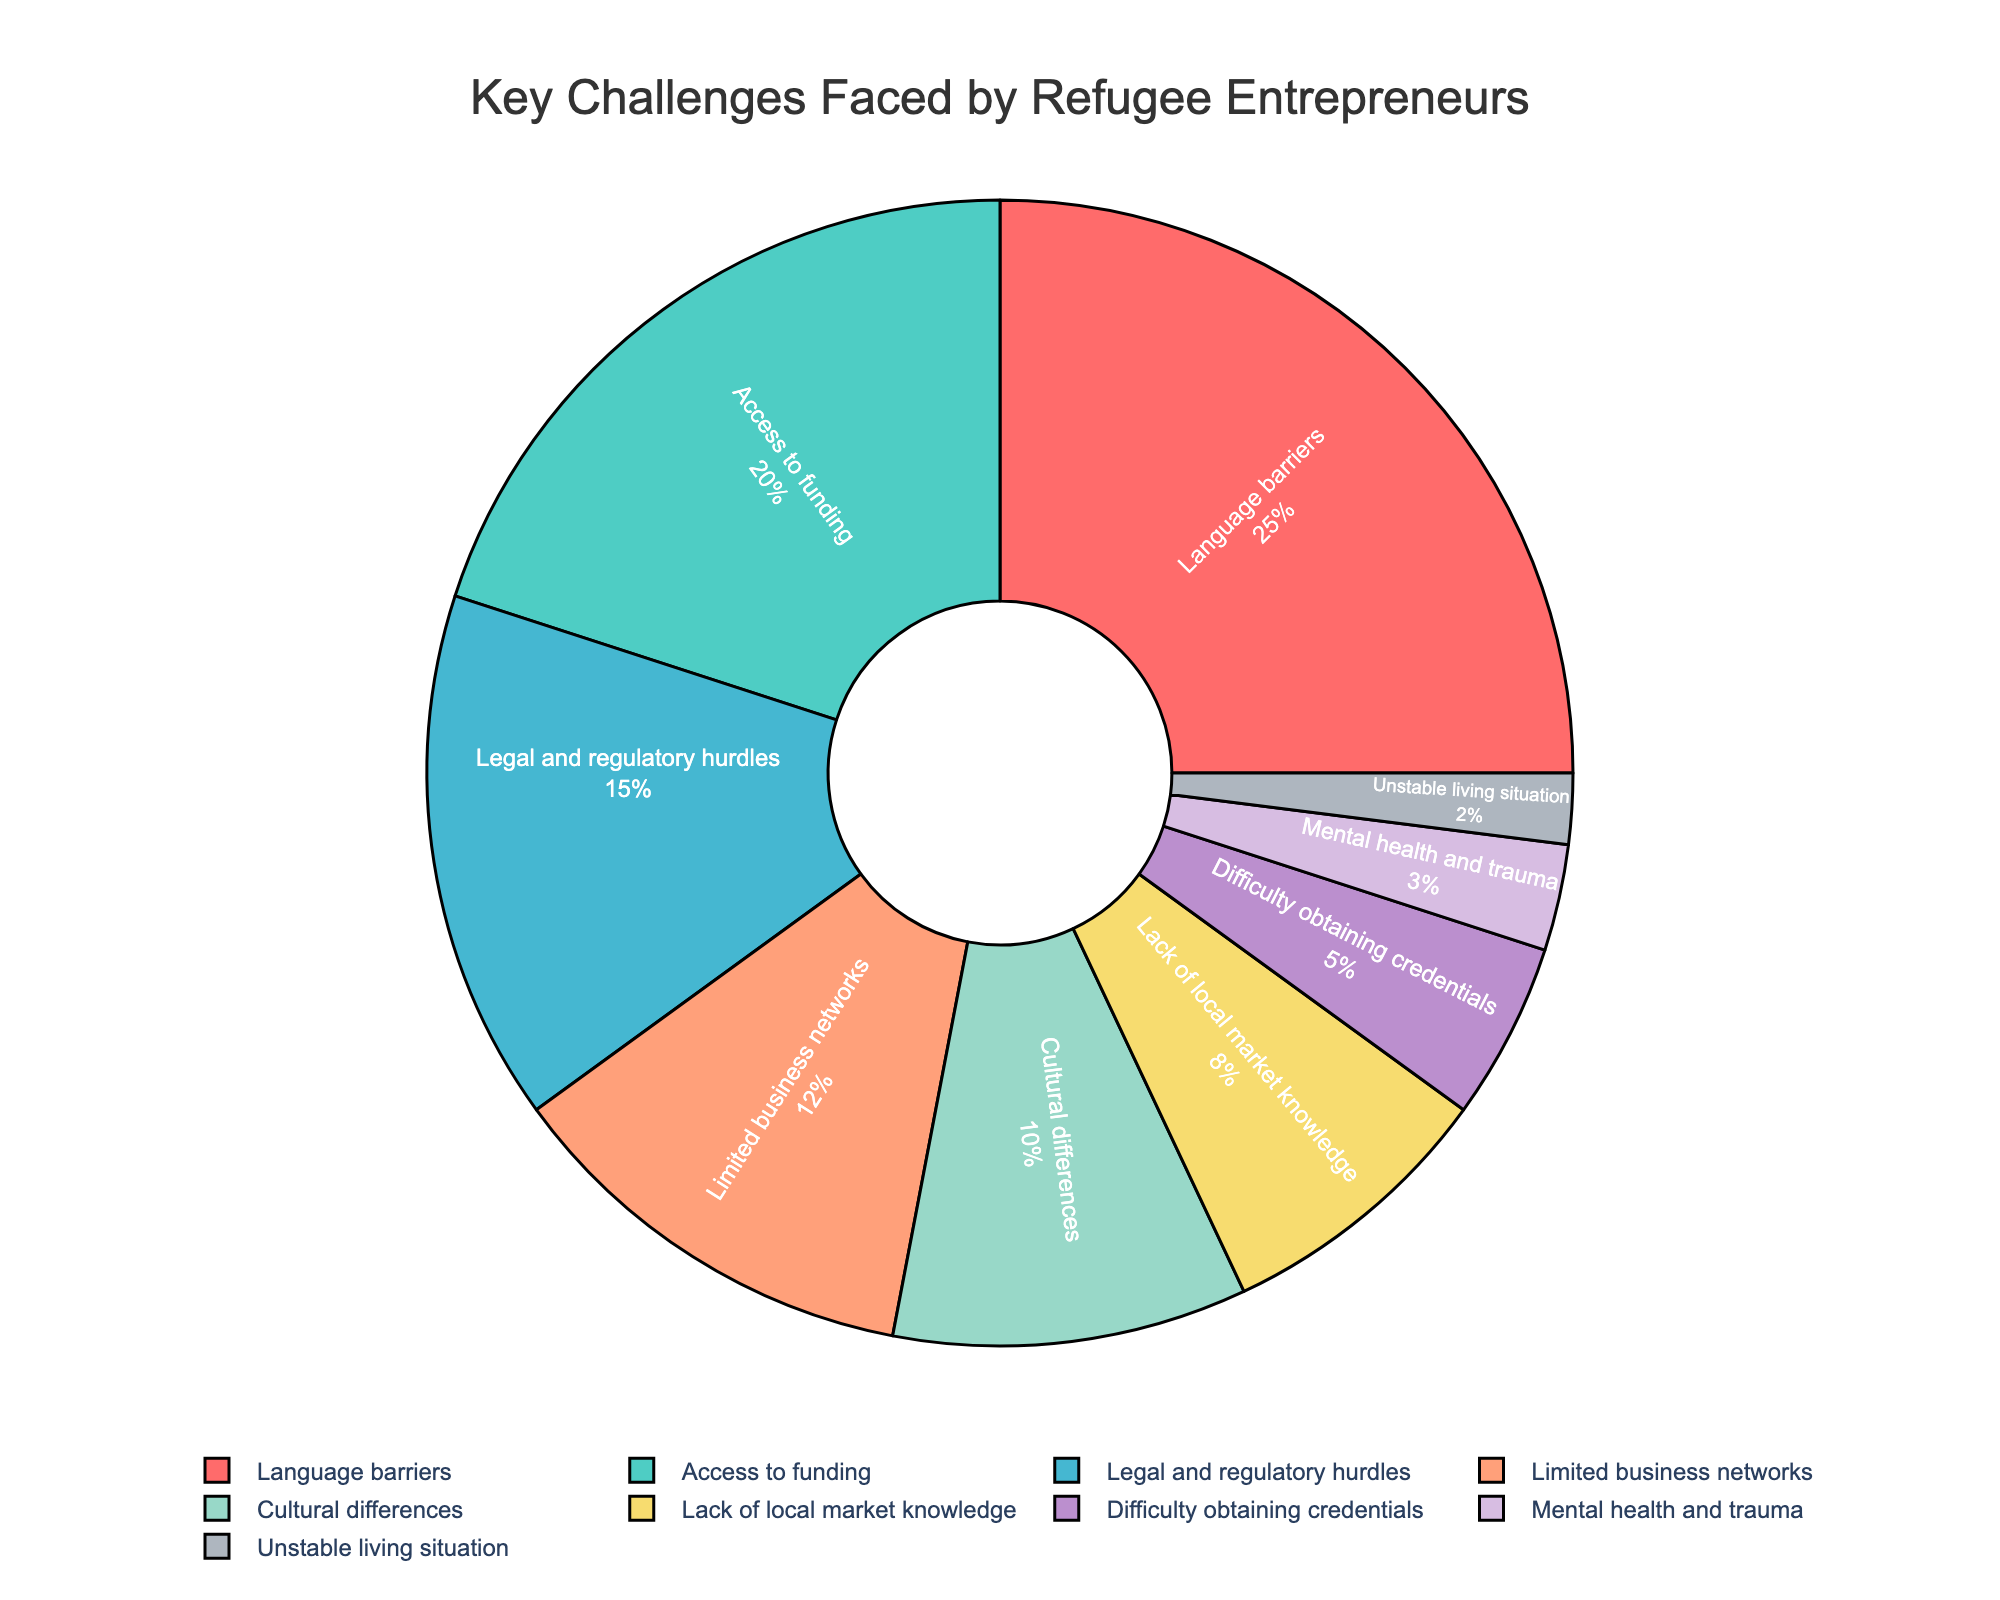What is the most significant challenge faced by refugee entrepreneurs? To determine the most significant challenge, we look for the slice of the pie chart that represents the largest percentage. The largest slice corresponds to "Language barriers" with 25%.
Answer: Language barriers Which challenge has the smallest impact on refugee entrepreneurs? The smallest slice of the pie chart indicates the area with the least percentage. The smallest slice corresponds to "Unstable living situation" at 2%.
Answer: Unstable living situation How much higher is the percentage of "Legal and regulatory hurdles" compared to "Difficulty obtaining credentials"? First, we find the percentages for both challenges: "Legal and regulatory hurdles" is 15%, and "Difficulty obtaining credentials" is 5%. The difference is 15% - 5% = 10%.
Answer: 10% What is the combined percentage of "Limited business networks" and "Cultural differences"? We add the percentages of "Limited business networks" (12%) and "Cultural differences" (10%). The combined percentage is 12% + 10% = 22%.
Answer: 22% What proportion of the challenges are related to financial constraints? Identify the financial-related challenges from the slices: "Access to funding" (20%). Since it is the only financial-related category, the percentage is 20%.
Answer: 20% How do "Cultural differences" and "Lack of local market knowledge" compare in their impact on refugee entrepreneurs? Compare the percentages for "Cultural differences" (10%) and "Lack of local market knowledge" (8%). "Cultural differences" has a higher impact.
Answer: Cultural differences What's the total percentage for challenges that are below 10%? Identify the challenges below 10% and sum their percentages: "Lack of local market knowledge" (8%), "Difficulty obtaining credentials" (5%), "Mental health and trauma" (3%), "Unstable living situation" (2%). The total is 8% + 5% + 3% + 2% = 18%.
Answer: 18% Which challenge is represented by the magenta slice on the pie chart? The magenta-colored slice represents "Mental health and trauma" at 3%.
Answer: Mental health and trauma What is the average percentage of "Access to funding," "Legal and regulatory hurdles," and "Limited business networks"? Calculate the average by summing the percentages of the three challenges and dividing by 3. (20% + 15% + 12%) / 3 = 47% / 3 = 15.67% (rounded to two decimal places).
Answer: 15.67% Which challenge has a larger percentage: "Language barriers" or the sum of "Difficulty obtaining credentials" and "Mental health and trauma"? Compare the percentage of "Language barriers" (25%) against the sum of "Difficulty obtaining credentials" (5%) and "Mental health and trauma" (3%), which is 5% + 3% = 8%. "Language barriers" has a larger percentage.
Answer: Language barriers 